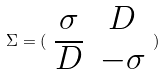Convert formula to latex. <formula><loc_0><loc_0><loc_500><loc_500>\Sigma = ( \begin{array} { c c } \sigma & D \\ \overline { D } & - \sigma \end{array} )</formula> 